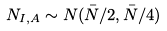<formula> <loc_0><loc_0><loc_500><loc_500>N _ { I , A } \sim N ( \bar { N } / 2 , \bar { N } / 4 )</formula> 